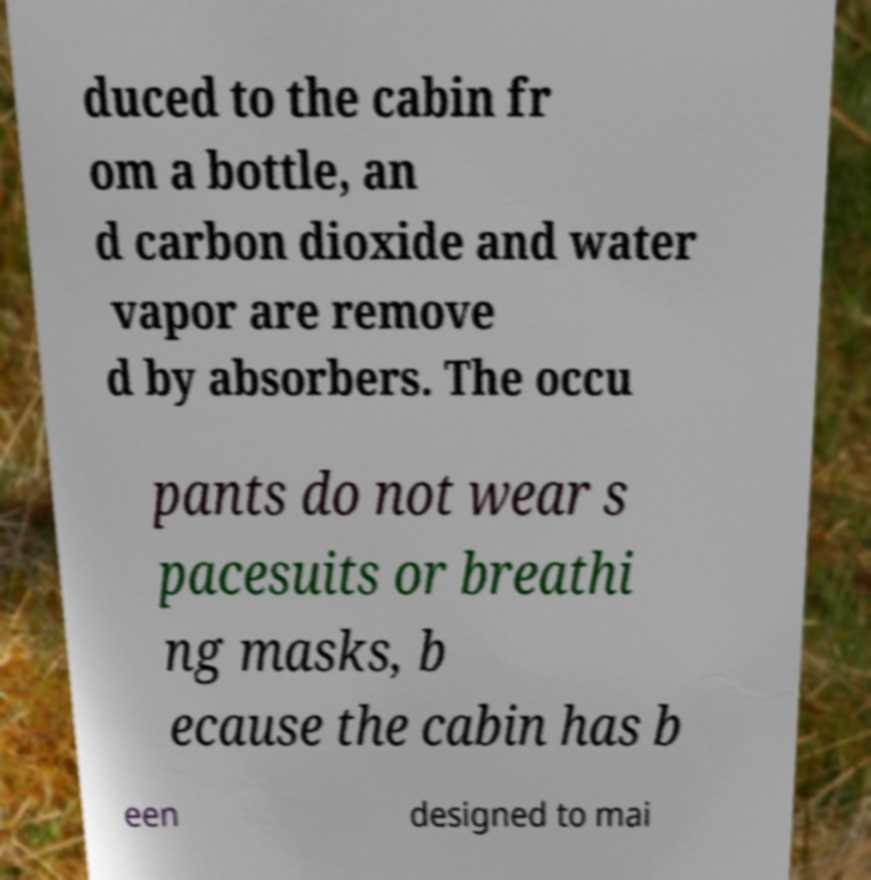Can you accurately transcribe the text from the provided image for me? duced to the cabin fr om a bottle, an d carbon dioxide and water vapor are remove d by absorbers. The occu pants do not wear s pacesuits or breathi ng masks, b ecause the cabin has b een designed to mai 